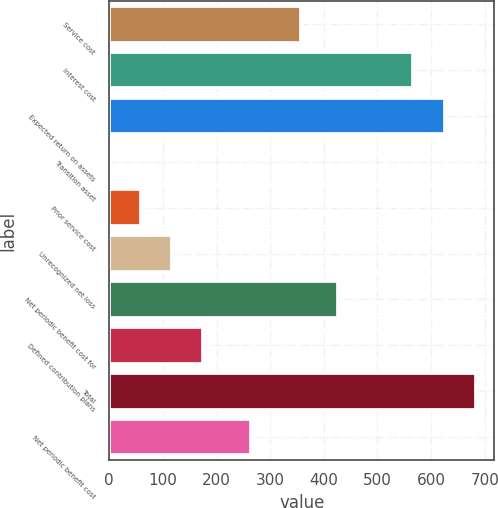Convert chart. <chart><loc_0><loc_0><loc_500><loc_500><bar_chart><fcel>Service cost<fcel>Interest cost<fcel>Expected return on assets<fcel>Transition asset<fcel>Prior service cost<fcel>Unrecognized net loss<fcel>Net periodic benefit cost for<fcel>Defined contribution plans<fcel>Total<fcel>Net periodic benefit cost<nl><fcel>358<fcel>567<fcel>625.2<fcel>1<fcel>59.2<fcel>117.4<fcel>427<fcel>175.6<fcel>683.4<fcel>264<nl></chart> 